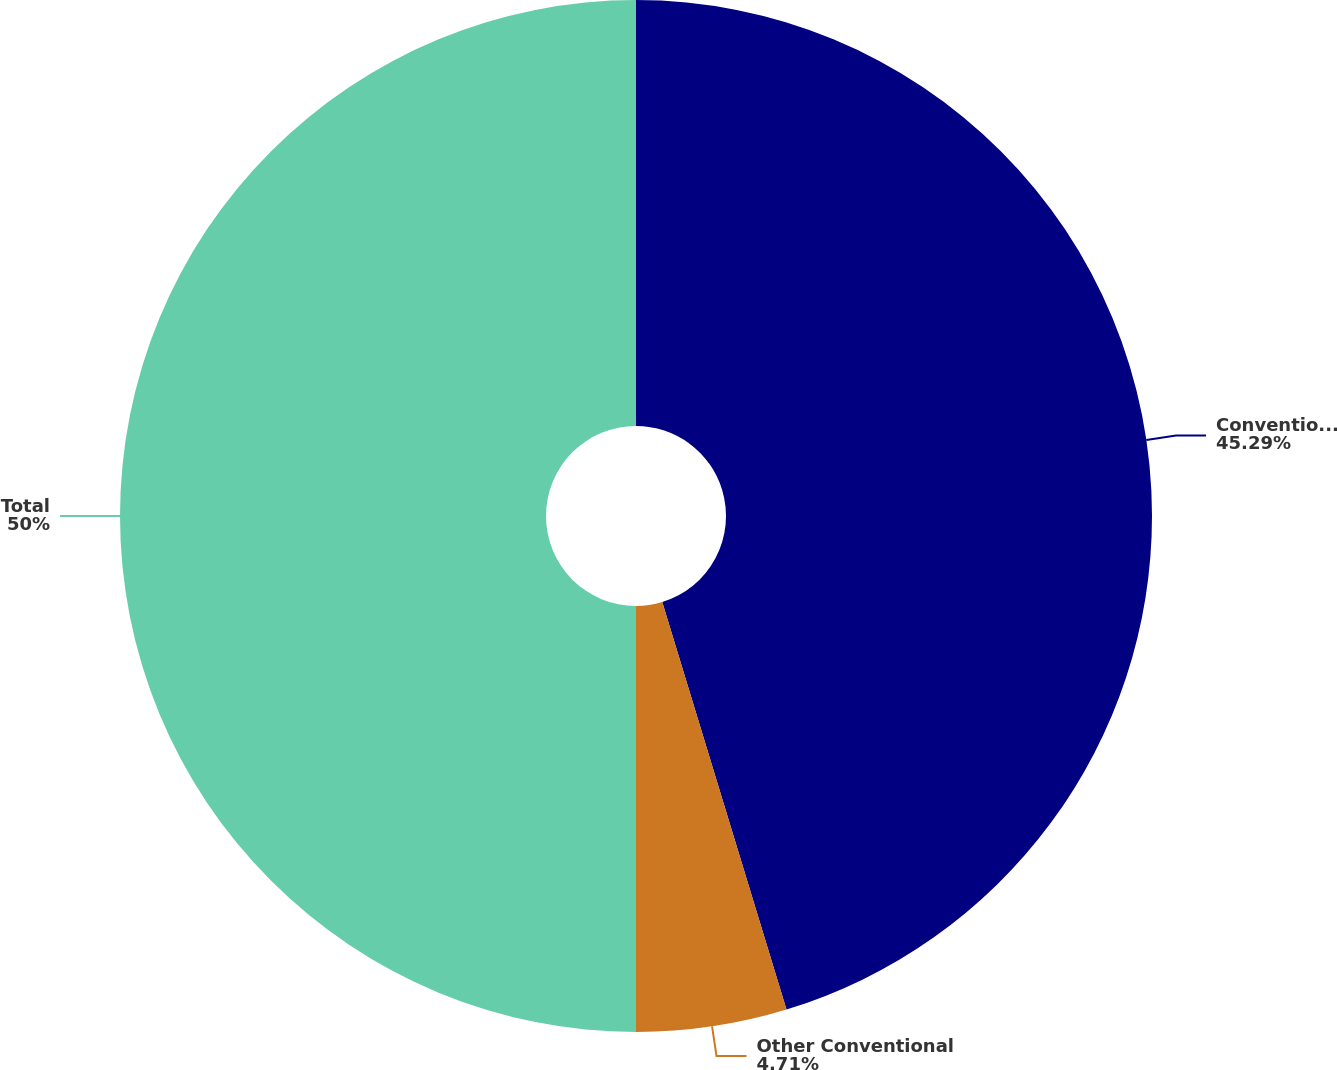Convert chart. <chart><loc_0><loc_0><loc_500><loc_500><pie_chart><fcel>Conventional same store<fcel>Other Conventional<fcel>Total<nl><fcel>45.29%<fcel>4.71%<fcel>50.0%<nl></chart> 